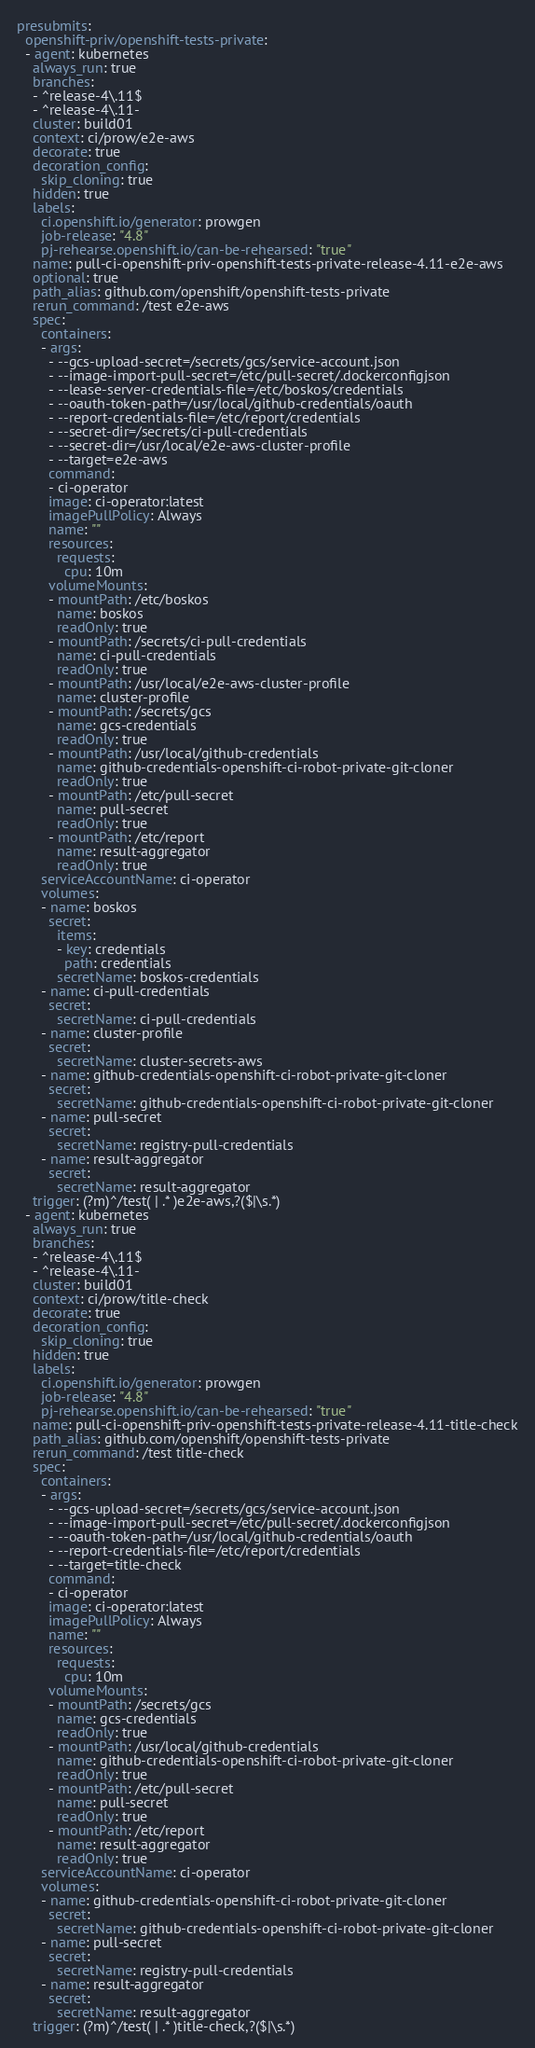<code> <loc_0><loc_0><loc_500><loc_500><_YAML_>presubmits:
  openshift-priv/openshift-tests-private:
  - agent: kubernetes
    always_run: true
    branches:
    - ^release-4\.11$
    - ^release-4\.11-
    cluster: build01
    context: ci/prow/e2e-aws
    decorate: true
    decoration_config:
      skip_cloning: true
    hidden: true
    labels:
      ci.openshift.io/generator: prowgen
      job-release: "4.8"
      pj-rehearse.openshift.io/can-be-rehearsed: "true"
    name: pull-ci-openshift-priv-openshift-tests-private-release-4.11-e2e-aws
    optional: true
    path_alias: github.com/openshift/openshift-tests-private
    rerun_command: /test e2e-aws
    spec:
      containers:
      - args:
        - --gcs-upload-secret=/secrets/gcs/service-account.json
        - --image-import-pull-secret=/etc/pull-secret/.dockerconfigjson
        - --lease-server-credentials-file=/etc/boskos/credentials
        - --oauth-token-path=/usr/local/github-credentials/oauth
        - --report-credentials-file=/etc/report/credentials
        - --secret-dir=/secrets/ci-pull-credentials
        - --secret-dir=/usr/local/e2e-aws-cluster-profile
        - --target=e2e-aws
        command:
        - ci-operator
        image: ci-operator:latest
        imagePullPolicy: Always
        name: ""
        resources:
          requests:
            cpu: 10m
        volumeMounts:
        - mountPath: /etc/boskos
          name: boskos
          readOnly: true
        - mountPath: /secrets/ci-pull-credentials
          name: ci-pull-credentials
          readOnly: true
        - mountPath: /usr/local/e2e-aws-cluster-profile
          name: cluster-profile
        - mountPath: /secrets/gcs
          name: gcs-credentials
          readOnly: true
        - mountPath: /usr/local/github-credentials
          name: github-credentials-openshift-ci-robot-private-git-cloner
          readOnly: true
        - mountPath: /etc/pull-secret
          name: pull-secret
          readOnly: true
        - mountPath: /etc/report
          name: result-aggregator
          readOnly: true
      serviceAccountName: ci-operator
      volumes:
      - name: boskos
        secret:
          items:
          - key: credentials
            path: credentials
          secretName: boskos-credentials
      - name: ci-pull-credentials
        secret:
          secretName: ci-pull-credentials
      - name: cluster-profile
        secret:
          secretName: cluster-secrets-aws
      - name: github-credentials-openshift-ci-robot-private-git-cloner
        secret:
          secretName: github-credentials-openshift-ci-robot-private-git-cloner
      - name: pull-secret
        secret:
          secretName: registry-pull-credentials
      - name: result-aggregator
        secret:
          secretName: result-aggregator
    trigger: (?m)^/test( | .* )e2e-aws,?($|\s.*)
  - agent: kubernetes
    always_run: true
    branches:
    - ^release-4\.11$
    - ^release-4\.11-
    cluster: build01
    context: ci/prow/title-check
    decorate: true
    decoration_config:
      skip_cloning: true
    hidden: true
    labels:
      ci.openshift.io/generator: prowgen
      job-release: "4.8"
      pj-rehearse.openshift.io/can-be-rehearsed: "true"
    name: pull-ci-openshift-priv-openshift-tests-private-release-4.11-title-check
    path_alias: github.com/openshift/openshift-tests-private
    rerun_command: /test title-check
    spec:
      containers:
      - args:
        - --gcs-upload-secret=/secrets/gcs/service-account.json
        - --image-import-pull-secret=/etc/pull-secret/.dockerconfigjson
        - --oauth-token-path=/usr/local/github-credentials/oauth
        - --report-credentials-file=/etc/report/credentials
        - --target=title-check
        command:
        - ci-operator
        image: ci-operator:latest
        imagePullPolicy: Always
        name: ""
        resources:
          requests:
            cpu: 10m
        volumeMounts:
        - mountPath: /secrets/gcs
          name: gcs-credentials
          readOnly: true
        - mountPath: /usr/local/github-credentials
          name: github-credentials-openshift-ci-robot-private-git-cloner
          readOnly: true
        - mountPath: /etc/pull-secret
          name: pull-secret
          readOnly: true
        - mountPath: /etc/report
          name: result-aggregator
          readOnly: true
      serviceAccountName: ci-operator
      volumes:
      - name: github-credentials-openshift-ci-robot-private-git-cloner
        secret:
          secretName: github-credentials-openshift-ci-robot-private-git-cloner
      - name: pull-secret
        secret:
          secretName: registry-pull-credentials
      - name: result-aggregator
        secret:
          secretName: result-aggregator
    trigger: (?m)^/test( | .* )title-check,?($|\s.*)
</code> 